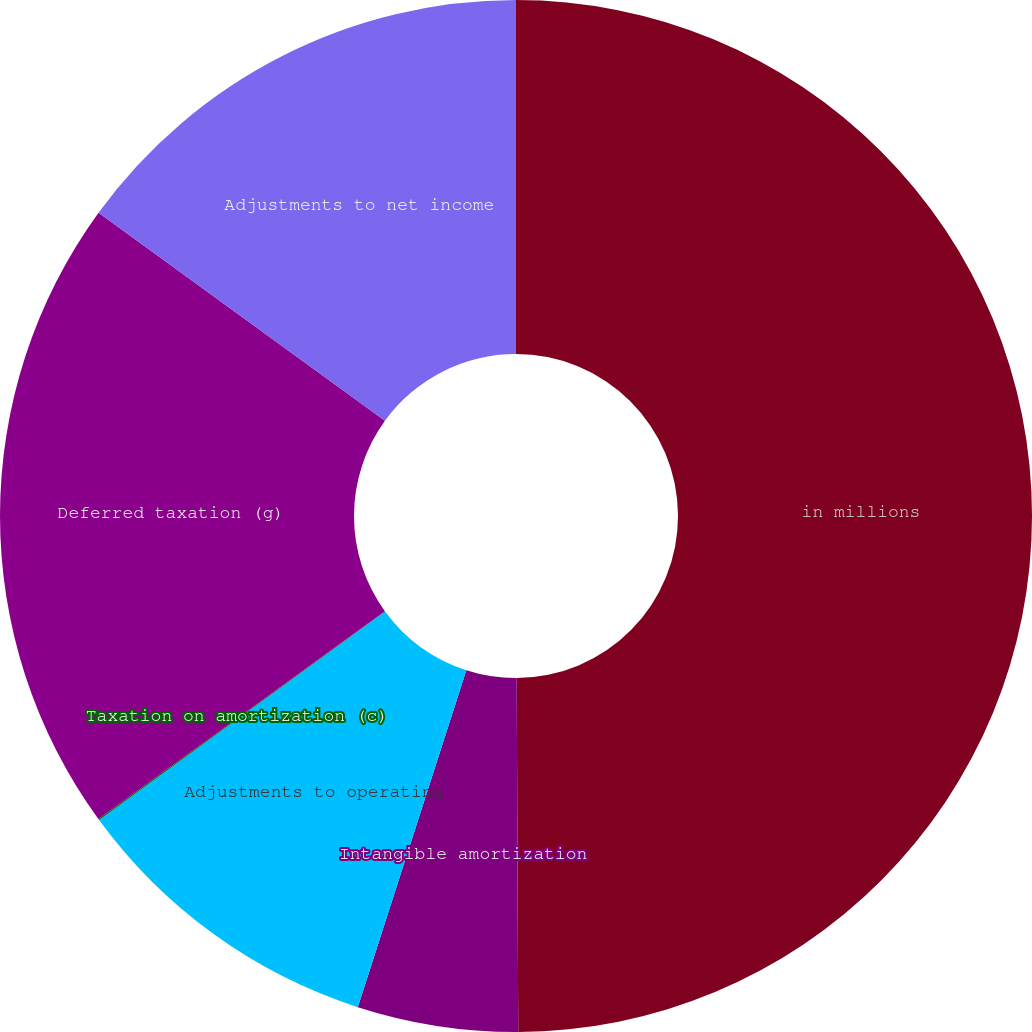<chart> <loc_0><loc_0><loc_500><loc_500><pie_chart><fcel>in millions<fcel>Intangible amortization<fcel>Adjustments to operating<fcel>Taxation on amortization (c)<fcel>Deferred taxation (g)<fcel>Adjustments to net income<nl><fcel>49.93%<fcel>5.03%<fcel>10.01%<fcel>0.04%<fcel>19.99%<fcel>15.0%<nl></chart> 